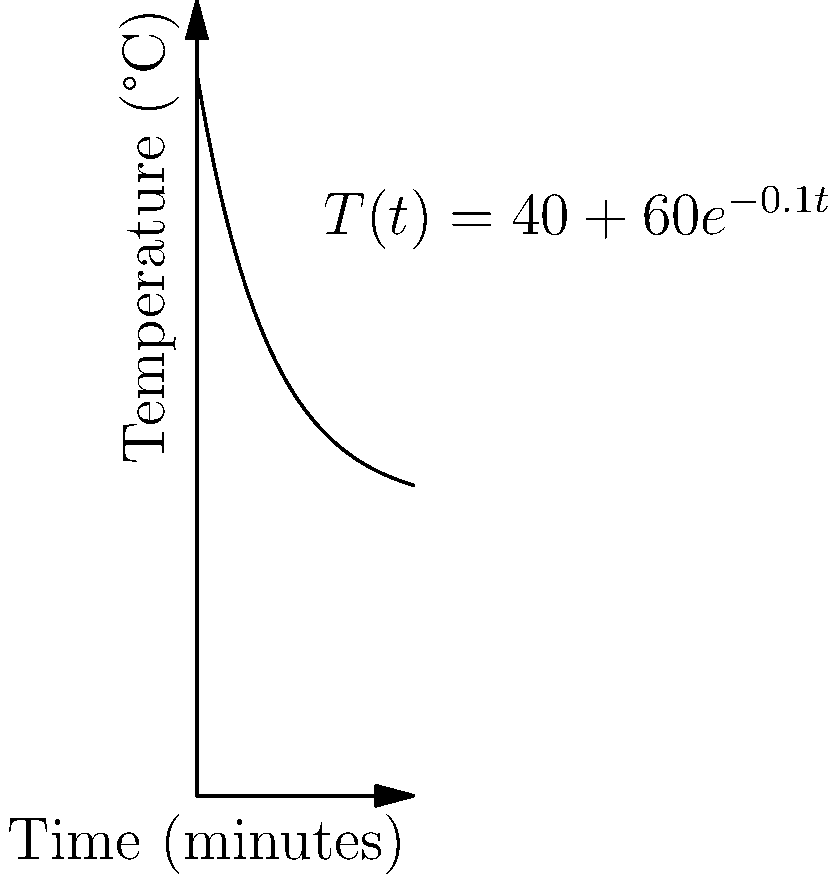The temperature $T$ (in °C) of a traditional Finnish sauna after $t$ minutes is modeled by the function $T(t) = 40 + 60e^{-0.1t}$. At what rate is the temperature changing after 10 minutes? To find the rate of change of temperature after 10 minutes, we need to calculate the derivative of the function $T(t)$ and then evaluate it at $t=10$.

Step 1: Find the derivative of $T(t)$.
$T(t) = 40 + 60e^{-0.1t}$
$T'(t) = 60 \cdot (-0.1) \cdot e^{-0.1t} = -6e^{-0.1t}$

Step 2: Evaluate $T'(t)$ at $t=10$.
$T'(10) = -6e^{-0.1 \cdot 10} = -6e^{-1} \approx -2.21$

The negative value indicates that the temperature is decreasing.

Step 3: Interpret the result.
The rate of change is approximately -2.21 °C per minute after 10 minutes.
Answer: $-2.21$ °C/min 